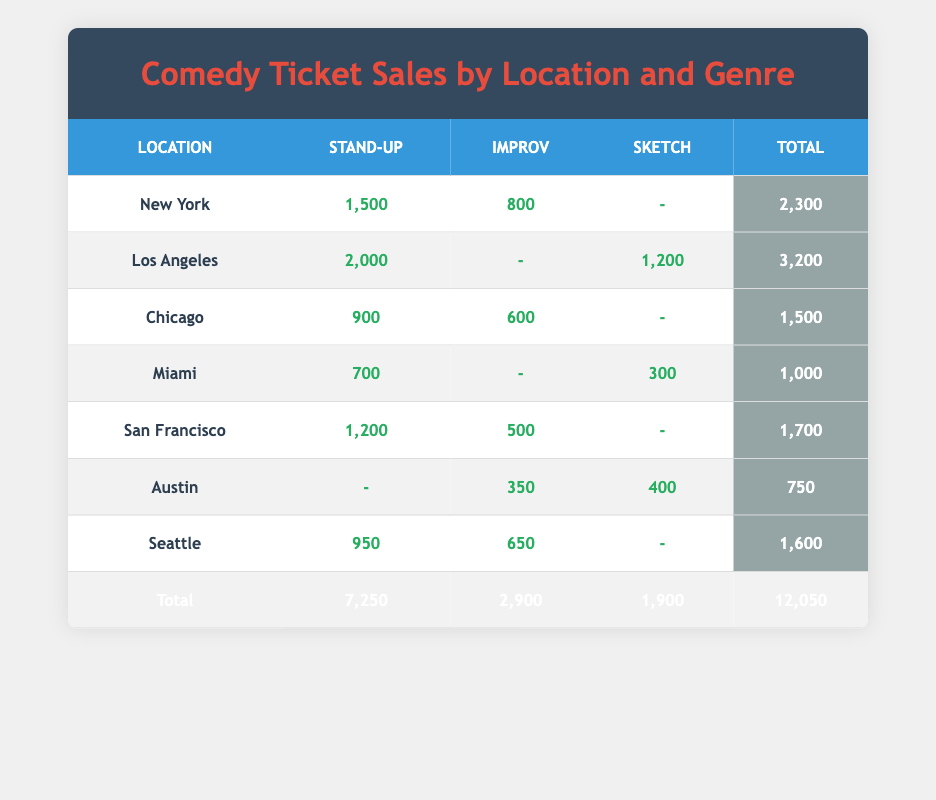What is the total ticket sales for Los Angeles? In the table for Los Angeles, the total sales are calculated by adding the Stand-Up sales (2000) and Sketch sales (1200) since there's no Improv sales. Therefore, 2000 + 1200 = 3200.
Answer: 3200 Which location has the highest sales for Stand-Up comedy? By checking the Stand-Up sales for each location, New York has 1500, Los Angeles has 2000, Chicago has 900, Miami has 700, San Francisco has 1200, Austin has no sales for Stand-Up, and Seattle has 950. The highest is Los Angeles with 2000.
Answer: Los Angeles Is there any location with no sales for Improv comedy? Reviewing the Improv sales, Austin has 350 and is a location with no sales for Stand-Up. Miami has no sales for Improv as well. Thus, the answer is yes, Miami has no Improv sales.
Answer: Yes What is the average ticket sales for Sketch comedy across all locations? The total Sketch sales are from Los Angeles (1200), Miami (300), and Austin (400), which sum up to 1900. There are three contributing locations, so the average is calculated as 1900 divided by 3, resulting in approximately 633.33.
Answer: 633.33 How many total sales are there from all locations for Improv? The Improv sales from each location are: New York (800), Chicago (600), San Francisco (500), Austin (350), and Seattle (650). Adding these together: 800 + 600 + 500 + 350 + 650 equals 2900.
Answer: 2900 What is the percentage of total sales that Stand-Up comedy constitutes? The total Stand-Up sales are 7250 (from all locations). Given that the grand total for all ticket sales is 12050, the percentage is calculated by (7250/12050) * 100, yielding approximately 60.25%.
Answer: 60.25% Which location has the lowest total ticket sales? Analyzing the total sales for each location shows Miami at 1000, Austin at 750, and others higher than those. The lowest total sales are from Austin, amounting to 750.
Answer: Austin Is the combined sales for Sketch comedy higher than Improv comedy? Adding the total Sketch sales (1900) and Improv sales (2900) indicates that Improv is higher. Therefore, the combined Sketch sales are not higher than Improv sales.
Answer: No 